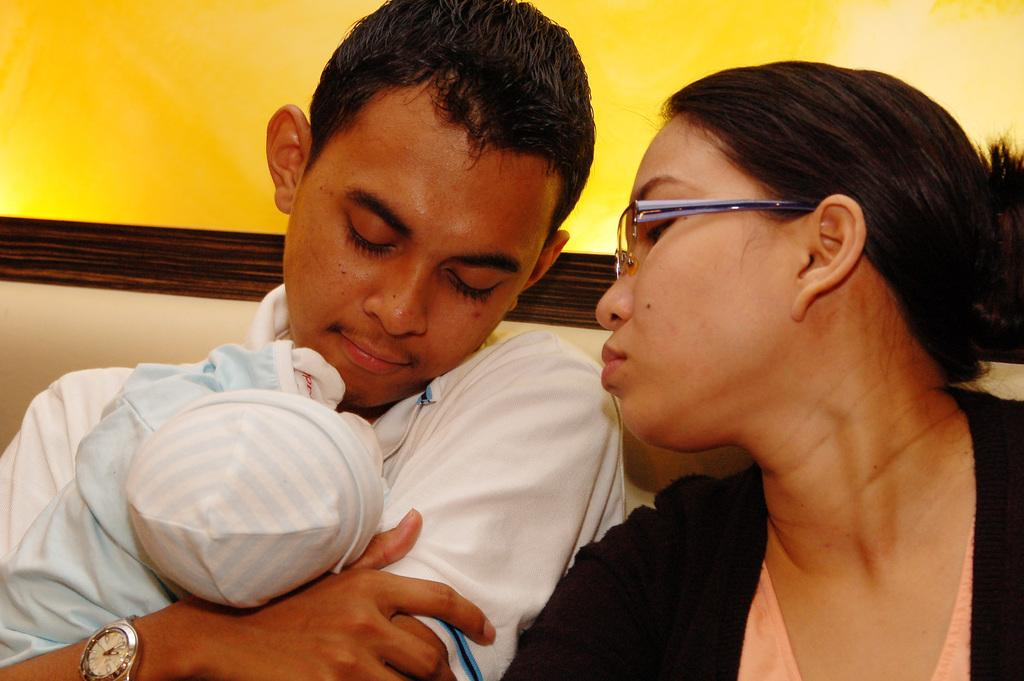How many persons are in the image? There are persons in the image. What are the persons wearing? The persons are wearing clothes. Where are the persons located in the image? The persons are in front of a wall. Can you describe the person on the right side of the image? The person on the right side of the image is wearing spectacles. What type of button is the achiever wearing on their shirt in the image? There is no achiever or button mentioned in the image. The image only features persons in front of a wall, and one of them is wearing spectacles. 